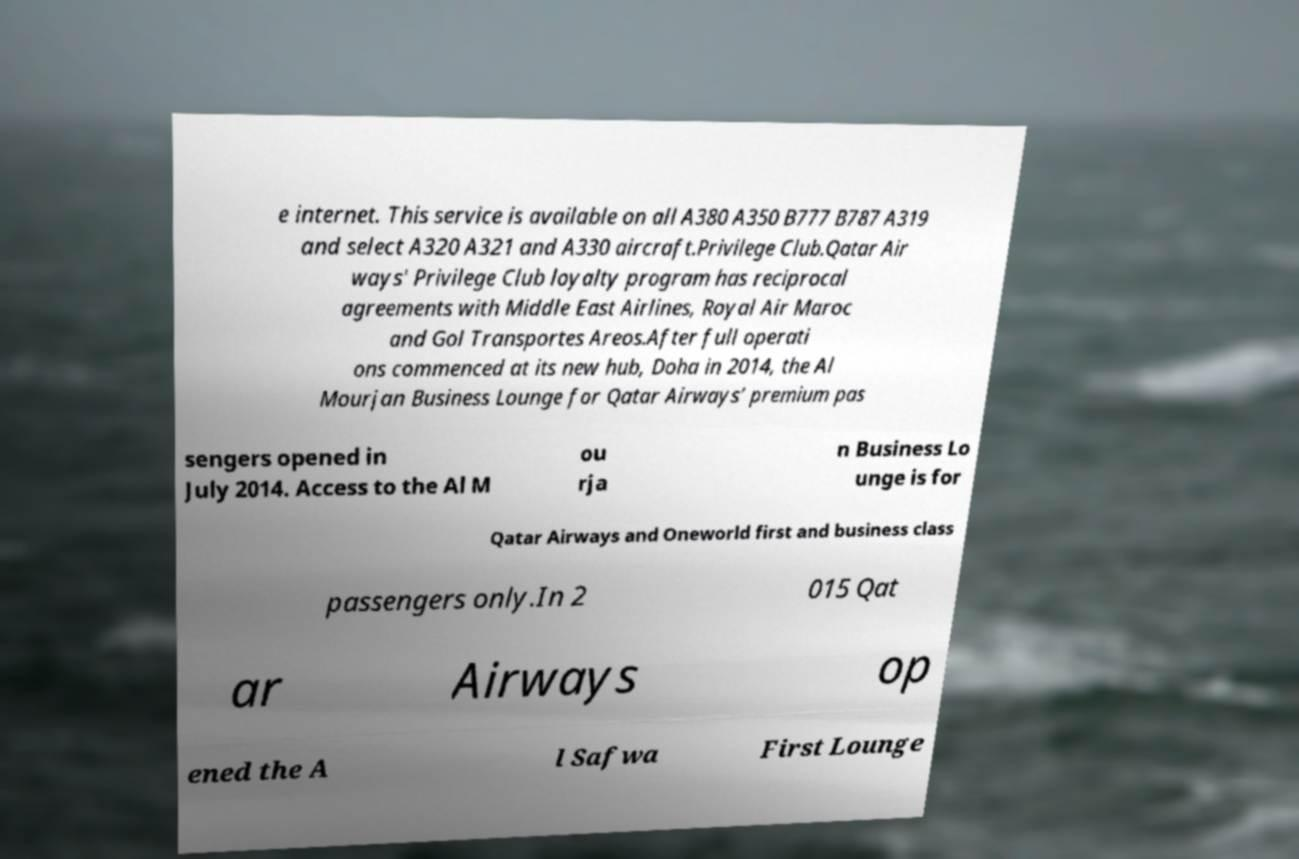Can you accurately transcribe the text from the provided image for me? e internet. This service is available on all A380 A350 B777 B787 A319 and select A320 A321 and A330 aircraft.Privilege Club.Qatar Air ways' Privilege Club loyalty program has reciprocal agreements with Middle East Airlines, Royal Air Maroc and Gol Transportes Areos.After full operati ons commenced at its new hub, Doha in 2014, the Al Mourjan Business Lounge for Qatar Airways’ premium pas sengers opened in July 2014. Access to the Al M ou rja n Business Lo unge is for Qatar Airways and Oneworld first and business class passengers only.In 2 015 Qat ar Airways op ened the A l Safwa First Lounge 